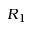Convert formula to latex. <formula><loc_0><loc_0><loc_500><loc_500>R _ { 1 }</formula> 